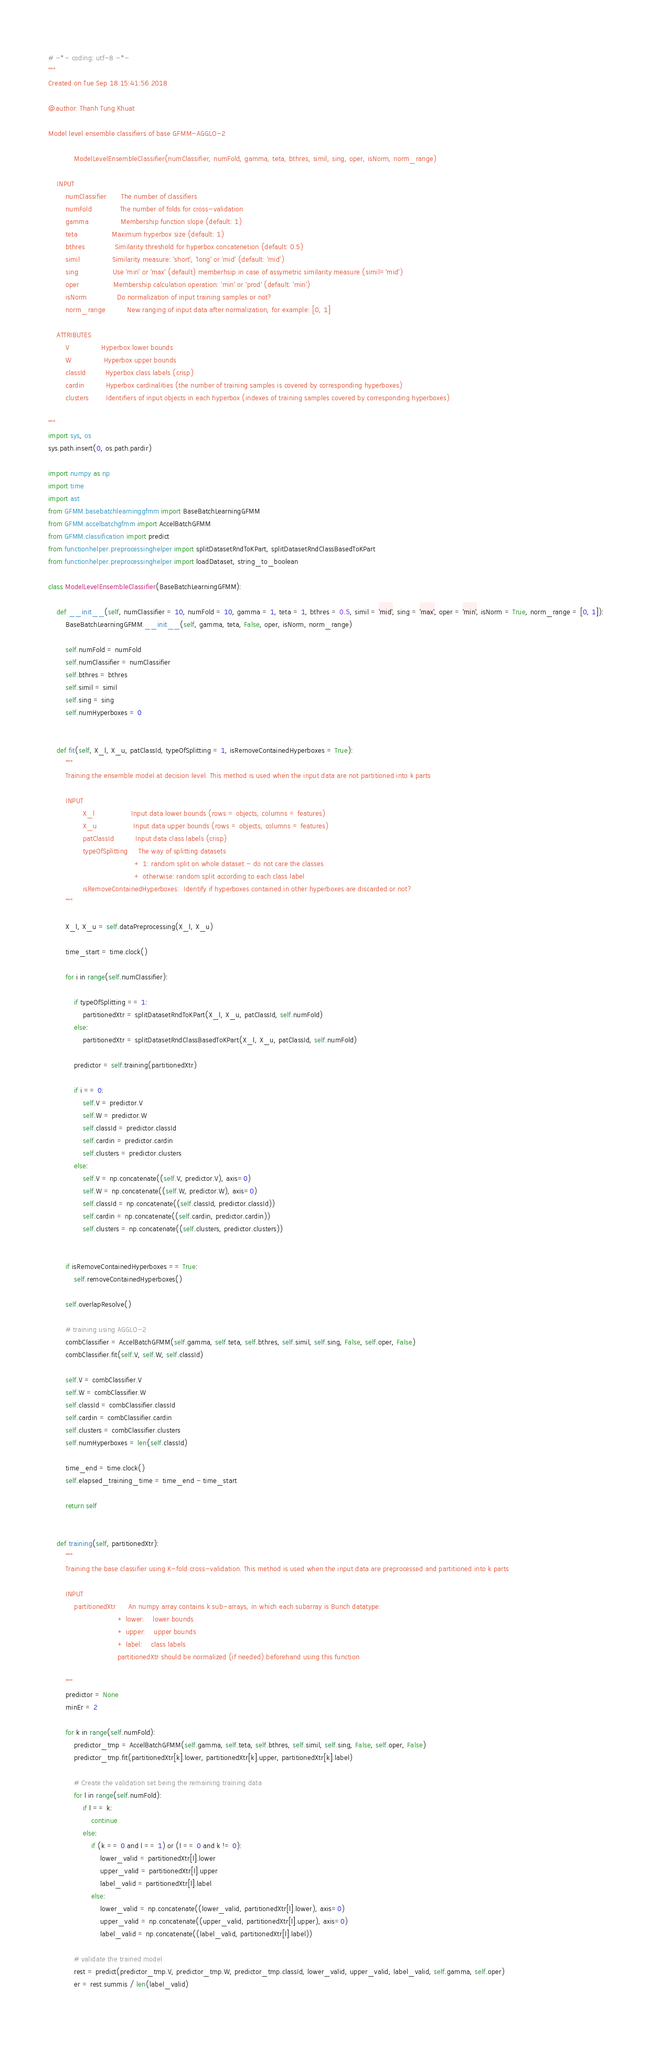<code> <loc_0><loc_0><loc_500><loc_500><_Python_># -*- coding: utf-8 -*-
"""
Created on Tue Sep 18 15:41:56 2018

@author: Thanh Tung Khuat

Model level ensemble classifiers of base GFMM-AGGLO-2

            ModelLevelEnsembleClassifier(numClassifier, numFold, gamma, teta, bthres, simil, sing, oper, isNorm, norm_range)

    INPUT
        numClassifier       The number of classifiers
        numFold             The number of folds for cross-validation
        gamma               Membership function slope (default: 1)
        teta                Maximum hyperbox size (default: 1)
        bthres              Similarity threshold for hyperbox concatenetion (default: 0.5)
        simil               Similarity measure: 'short', 'long' or 'mid' (default: 'mid')
        sing                Use 'min' or 'max' (default) memberhsip in case of assymetric similarity measure (simil='mid')
        oper                Membership calculation operation: 'min' or 'prod' (default: 'min')
        isNorm              Do normalization of input training samples or not?
        norm_range          New ranging of input data after normalization, for example: [0, 1]
        
    ATTRIBUTES
        V               Hyperbox lower bounds
        W               Hyperbox upper bounds
        classId         Hyperbox class labels (crisp)
        cardin          Hyperbox cardinalities (the number of training samples is covered by corresponding hyperboxes)
        clusters        Identifiers of input objects in each hyperbox (indexes of training samples covered by corresponding hyperboxes)

"""
import sys, os
sys.path.insert(0, os.path.pardir)

import numpy as np
import time
import ast
from GFMM.basebatchlearninggfmm import BaseBatchLearningGFMM
from GFMM.accelbatchgfmm import AccelBatchGFMM
from GFMM.classification import predict
from functionhelper.preprocessinghelper import splitDatasetRndToKPart, splitDatasetRndClassBasedToKPart
from functionhelper.preprocessinghelper import loadDataset, string_to_boolean

class ModelLevelEnsembleClassifier(BaseBatchLearningGFMM):
    
    def __init__(self, numClassifier = 10, numFold = 10, gamma = 1, teta = 1, bthres = 0.5, simil = 'mid', sing = 'max', oper = 'min', isNorm = True, norm_range = [0, 1]):
        BaseBatchLearningGFMM.__init__(self, gamma, teta, False, oper, isNorm, norm_range)
        
        self.numFold = numFold
        self.numClassifier = numClassifier
        self.bthres = bthres
        self.simil = simil
        self.sing = sing
        self.numHyperboxes = 0
    
    
    def fit(self, X_l, X_u, patClassId, typeOfSplitting = 1, isRemoveContainedHyperboxes = True):
        """
        Training the ensemble model at decision level. This method is used when the input data are not partitioned into k parts
        
        INPUT
                X_l                 Input data lower bounds (rows = objects, columns = features)
                X_u                 Input data upper bounds (rows = objects, columns = features)
                patClassId          Input data class labels (crisp)
                typeOfSplitting     The way of splitting datasets
                                        + 1: random split on whole dataset - do not care the classes
                                        + otherwise: random split according to each class label
                isRemoveContainedHyperboxes:  Identify if hyperboxes contained in other hyperboxes are discarded or not?
        """

        X_l, X_u = self.dataPreprocessing(X_l, X_u)
        
        time_start = time.clock()
        
        for i in range(self.numClassifier):
        
            if typeOfSplitting == 1:
                partitionedXtr = splitDatasetRndToKPart(X_l, X_u, patClassId, self.numFold)
            else:
                partitionedXtr = splitDatasetRndClassBasedToKPart(X_l, X_u, patClassId, self.numFold)
                
            predictor = self.training(partitionedXtr)
            
            if i == 0:
                self.V = predictor.V
                self.W = predictor.W
                self.classId = predictor.classId
                self.cardin = predictor.cardin
                self.clusters = predictor.clusters
            else:
                self.V = np.concatenate((self.V, predictor.V), axis=0)
                self.W = np.concatenate((self.W, predictor.W), axis=0)
                self.classId = np.concatenate((self.classId, predictor.classId))
                self.cardin = np.concatenate((self.cardin, predictor.cardin))
                self.clusters = np.concatenate((self.clusters, predictor.clusters))
                
            
        if isRemoveContainedHyperboxes == True:
            self.removeContainedHyperboxes()
            
        self.overlapResolve()
        
        # training using AGGLO-2
        combClassifier = AccelBatchGFMM(self.gamma, self.teta, self.bthres, self.simil, self.sing, False, self.oper, False)
        combClassifier.fit(self.V, self.W, self.classId)
        
        self.V = combClassifier.V
        self.W = combClassifier.W
        self.classId = combClassifier.classId
        self.cardin = combClassifier.cardin
        self.clusters = combClassifier.clusters
        self.numHyperboxes = len(self.classId)
        
        time_end = time.clock()
        self.elapsed_training_time = time_end - time_start
        
        return self
              
    
    def training(self, partitionedXtr):
        """
        Training the base classifier using K-fold cross-validation. This method is used when the input data are preprocessed and partitioned into k parts
        
        INPUT
            partitionedXtr      An numpy array contains k sub-arrays, in which each subarray is Bunch datatype:
                                + lower:    lower bounds
                                + upper:    upper bounds
                                + label:    class labels
                                partitionedXtr should be normalized (if needed) beforehand using this function
                                
        """
        predictor = None     
        minEr = 2
        
        for k in range(self.numFold):
            predictor_tmp = AccelBatchGFMM(self.gamma, self.teta, self.bthres, self.simil, self.sing, False, self.oper, False)
            predictor_tmp.fit(partitionedXtr[k].lower, partitionedXtr[k].upper, partitionedXtr[k].label)
            
            # Create the validation set being the remaining training data
            for l in range(self.numFold):
                if l == k:
                    continue
                else:
                    if (k == 0 and l == 1) or (l == 0 and k != 0):
                        lower_valid = partitionedXtr[l].lower
                        upper_valid = partitionedXtr[l].upper
                        label_valid = partitionedXtr[l].label
                    else:
                        lower_valid = np.concatenate((lower_valid, partitionedXtr[l].lower), axis=0)
                        upper_valid = np.concatenate((upper_valid, partitionedXtr[l].upper), axis=0)
                        label_valid = np.concatenate((label_valid, partitionedXtr[l].label))
            
            # validate the trained model
            rest = predict(predictor_tmp.V, predictor_tmp.W, predictor_tmp.classId, lower_valid, upper_valid, label_valid, self.gamma, self.oper)
            er = rest.summis / len(label_valid)
            </code> 